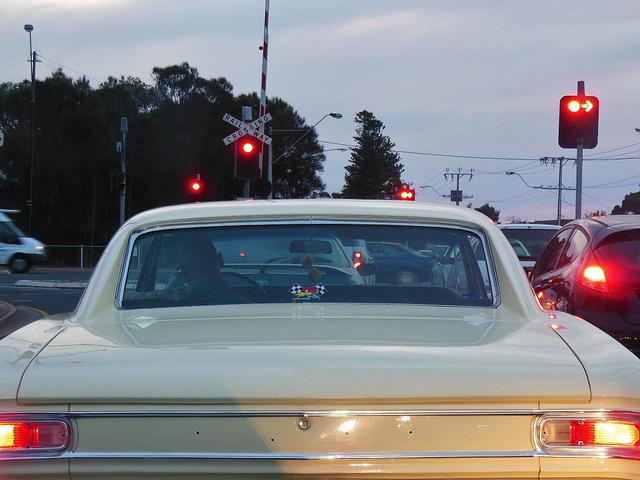There are a line of cars at the intersection because of what reason? Please explain your reasoning. traffic light. The light here is red.  you stop on red. 